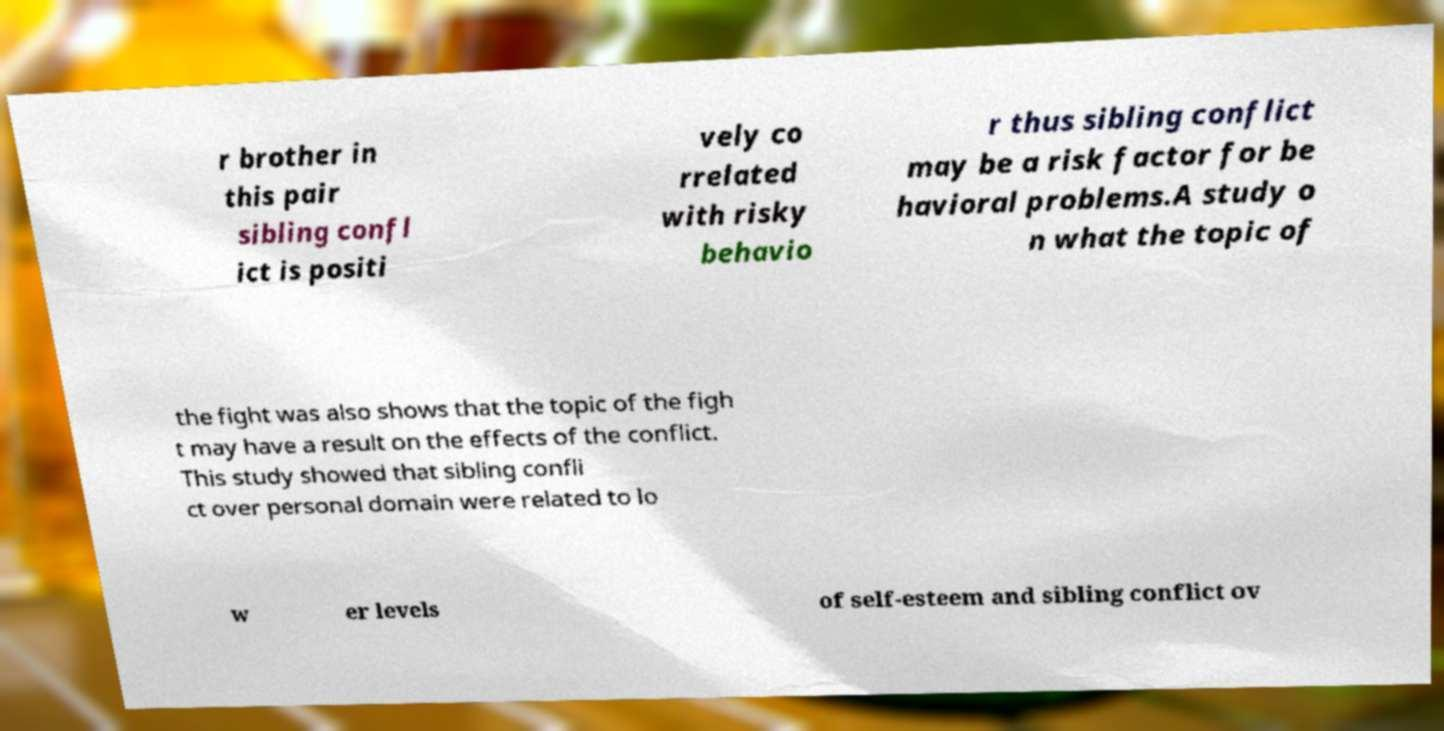What messages or text are displayed in this image? I need them in a readable, typed format. r brother in this pair sibling confl ict is positi vely co rrelated with risky behavio r thus sibling conflict may be a risk factor for be havioral problems.A study o n what the topic of the fight was also shows that the topic of the figh t may have a result on the effects of the conflict. This study showed that sibling confli ct over personal domain were related to lo w er levels of self-esteem and sibling conflict ov 